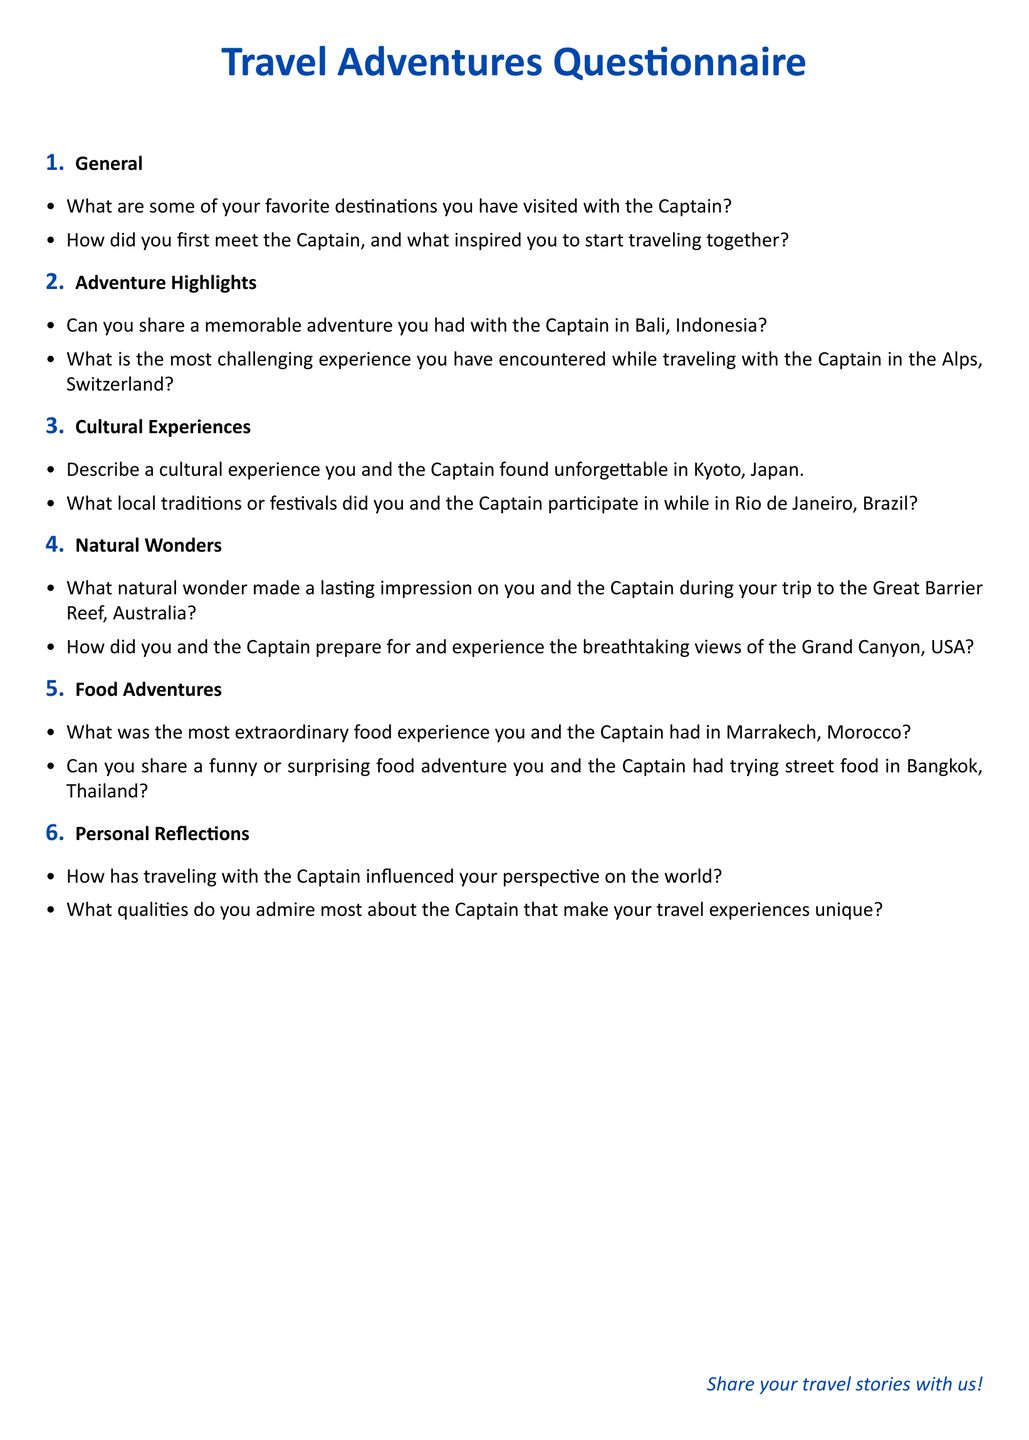What are some favorite destinations you have visited? The document asks for favorite destinations visited with the Captain, which could include multiple locations.
Answer: Not specified What is the first adventure highlighted in the document? The first highlighted adventure relates to a memorable experience in Bali, Indonesia, shared with the Captain.
Answer: Bali, Indonesia What challenging experience is mentioned in relation to the Alps? The document queries about the most challenging experience encountered while traveling with the Captain in the Alps, which prompts a reflective answer.
Answer: Not specified What memorable cultural experience is mentioned in Kyoto? The questionnaire seeks to understand unforgettable cultural experiences in Kyoto that you shared with the Captain.
Answer: Not specified What is the focus of the food adventure in Marrakech? The specific focus is on the most extraordinary food experience had in Marrakech with the Captain.
Answer: Not specified 